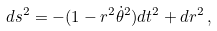Convert formula to latex. <formula><loc_0><loc_0><loc_500><loc_500>d s ^ { 2 } = - ( 1 - r ^ { 2 } \dot { \theta } ^ { 2 } ) d t ^ { 2 } + d r ^ { 2 } \, ,</formula> 